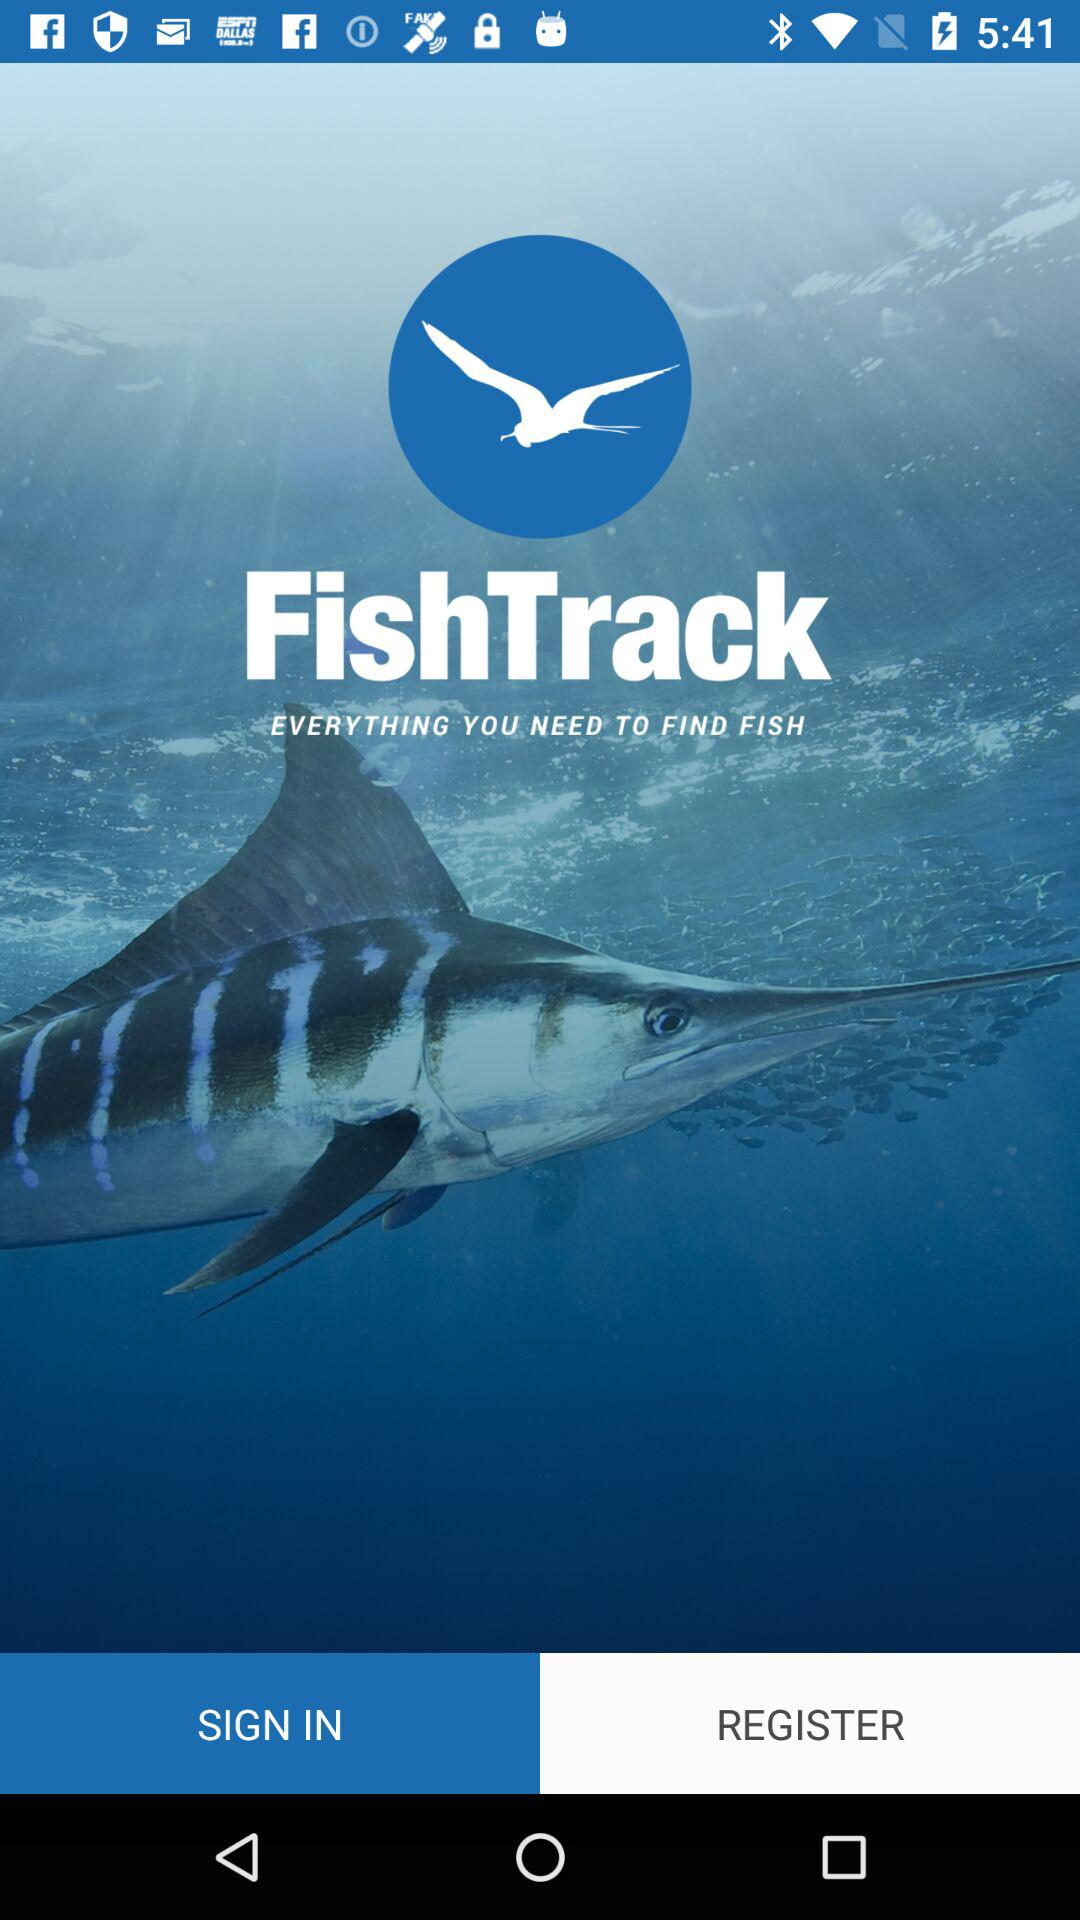Which option is selected at the bottom?
When the provided information is insufficient, respond with <no answer>. <no answer> 